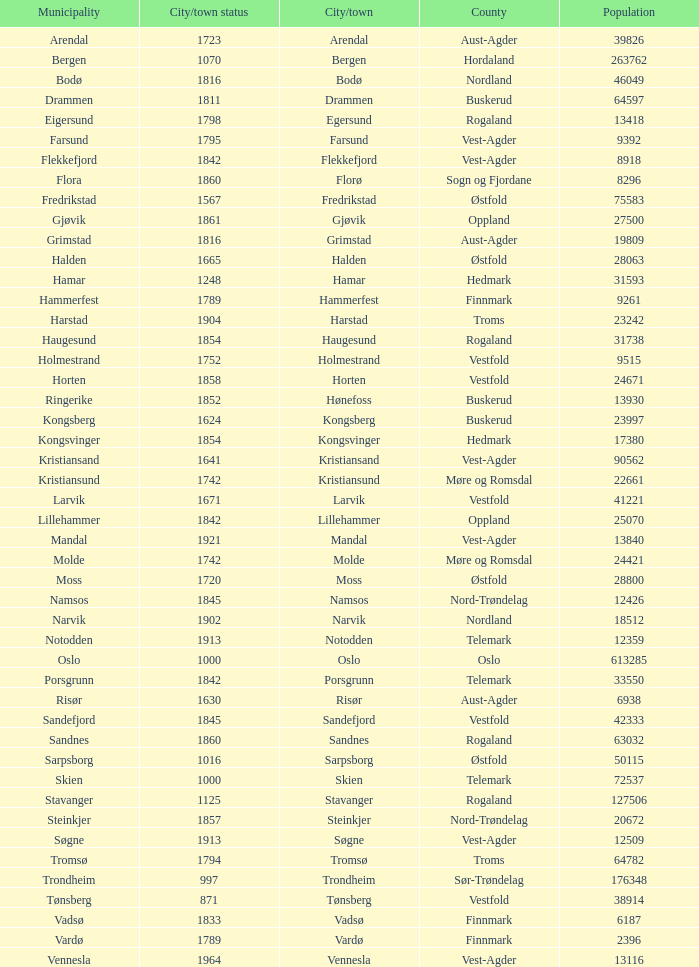What is the total population in the city/town of Arendal? 1.0. Could you parse the entire table? {'header': ['Municipality', 'City/town status', 'City/town', 'County', 'Population'], 'rows': [['Arendal', '1723', 'Arendal', 'Aust-Agder', '39826'], ['Bergen', '1070', 'Bergen', 'Hordaland', '263762'], ['Bodø', '1816', 'Bodø', 'Nordland', '46049'], ['Drammen', '1811', 'Drammen', 'Buskerud', '64597'], ['Eigersund', '1798', 'Egersund', 'Rogaland', '13418'], ['Farsund', '1795', 'Farsund', 'Vest-Agder', '9392'], ['Flekkefjord', '1842', 'Flekkefjord', 'Vest-Agder', '8918'], ['Flora', '1860', 'Florø', 'Sogn og Fjordane', '8296'], ['Fredrikstad', '1567', 'Fredrikstad', 'Østfold', '75583'], ['Gjøvik', '1861', 'Gjøvik', 'Oppland', '27500'], ['Grimstad', '1816', 'Grimstad', 'Aust-Agder', '19809'], ['Halden', '1665', 'Halden', 'Østfold', '28063'], ['Hamar', '1248', 'Hamar', 'Hedmark', '31593'], ['Hammerfest', '1789', 'Hammerfest', 'Finnmark', '9261'], ['Harstad', '1904', 'Harstad', 'Troms', '23242'], ['Haugesund', '1854', 'Haugesund', 'Rogaland', '31738'], ['Holmestrand', '1752', 'Holmestrand', 'Vestfold', '9515'], ['Horten', '1858', 'Horten', 'Vestfold', '24671'], ['Ringerike', '1852', 'Hønefoss', 'Buskerud', '13930'], ['Kongsberg', '1624', 'Kongsberg', 'Buskerud', '23997'], ['Kongsvinger', '1854', 'Kongsvinger', 'Hedmark', '17380'], ['Kristiansand', '1641', 'Kristiansand', 'Vest-Agder', '90562'], ['Kristiansund', '1742', 'Kristiansund', 'Møre og Romsdal', '22661'], ['Larvik', '1671', 'Larvik', 'Vestfold', '41221'], ['Lillehammer', '1842', 'Lillehammer', 'Oppland', '25070'], ['Mandal', '1921', 'Mandal', 'Vest-Agder', '13840'], ['Molde', '1742', 'Molde', 'Møre og Romsdal', '24421'], ['Moss', '1720', 'Moss', 'Østfold', '28800'], ['Namsos', '1845', 'Namsos', 'Nord-Trøndelag', '12426'], ['Narvik', '1902', 'Narvik', 'Nordland', '18512'], ['Notodden', '1913', 'Notodden', 'Telemark', '12359'], ['Oslo', '1000', 'Oslo', 'Oslo', '613285'], ['Porsgrunn', '1842', 'Porsgrunn', 'Telemark', '33550'], ['Risør', '1630', 'Risør', 'Aust-Agder', '6938'], ['Sandefjord', '1845', 'Sandefjord', 'Vestfold', '42333'], ['Sandnes', '1860', 'Sandnes', 'Rogaland', '63032'], ['Sarpsborg', '1016', 'Sarpsborg', 'Østfold', '50115'], ['Skien', '1000', 'Skien', 'Telemark', '72537'], ['Stavanger', '1125', 'Stavanger', 'Rogaland', '127506'], ['Steinkjer', '1857', 'Steinkjer', 'Nord-Trøndelag', '20672'], ['Søgne', '1913', 'Søgne', 'Vest-Agder', '12509'], ['Tromsø', '1794', 'Tromsø', 'Troms', '64782'], ['Trondheim', '997', 'Trondheim', 'Sør-Trøndelag', '176348'], ['Tønsberg', '871', 'Tønsberg', 'Vestfold', '38914'], ['Vadsø', '1833', 'Vadsø', 'Finnmark', '6187'], ['Vardø', '1789', 'Vardø', 'Finnmark', '2396'], ['Vennesla', '1964', 'Vennesla', 'Vest-Agder', '13116']]} 